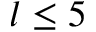<formula> <loc_0><loc_0><loc_500><loc_500>l \leq 5</formula> 